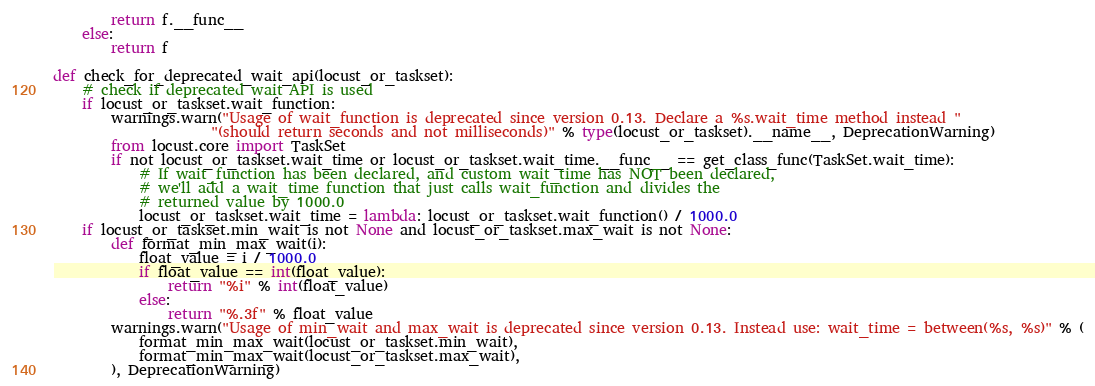Convert code to text. <code><loc_0><loc_0><loc_500><loc_500><_Python_>        return f.__func__
    else:
        return f

def check_for_deprecated_wait_api(locust_or_taskset):
    # check if deprecated wait API is used
    if locust_or_taskset.wait_function:
        warnings.warn("Usage of wait_function is deprecated since version 0.13. Declare a %s.wait_time method instead "
                      "(should return seconds and not milliseconds)" % type(locust_or_taskset).__name__, DeprecationWarning)
        from locust.core import TaskSet
        if not locust_or_taskset.wait_time or locust_or_taskset.wait_time.__func__ == get_class_func(TaskSet.wait_time):
            # If wait_function has been declared, and custom wait_time has NOT been declared, 
            # we'll add a wait_time function that just calls wait_function and divides the 
            # returned value by 1000.0
            locust_or_taskset.wait_time = lambda: locust_or_taskset.wait_function() / 1000.0
    if locust_or_taskset.min_wait is not None and locust_or_taskset.max_wait is not None:
        def format_min_max_wait(i):
            float_value = i / 1000.0
            if float_value == int(float_value):
                return "%i" % int(float_value)
            else:
                return "%.3f" % float_value
        warnings.warn("Usage of min_wait and max_wait is deprecated since version 0.13. Instead use: wait_time = between(%s, %s)" % (
            format_min_max_wait(locust_or_taskset.min_wait),
            format_min_max_wait(locust_or_taskset.max_wait),
        ), DeprecationWarning)
</code> 